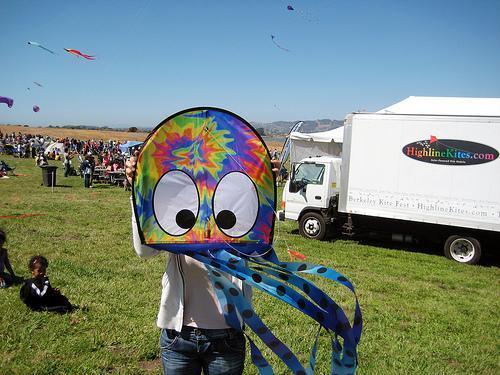How many children are behind the person?
Give a very brief answer. 1. 